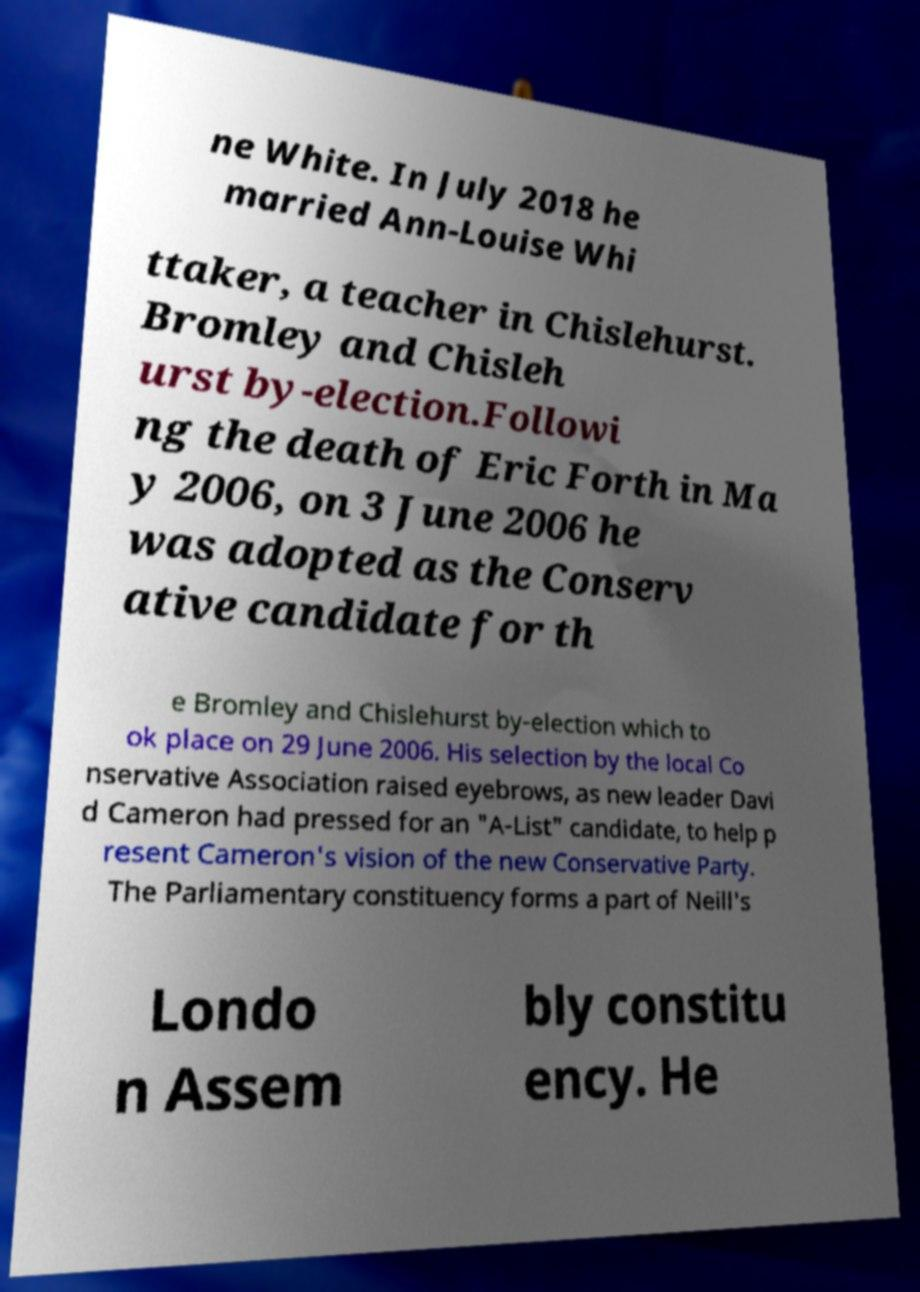There's text embedded in this image that I need extracted. Can you transcribe it verbatim? ne White. In July 2018 he married Ann-Louise Whi ttaker, a teacher in Chislehurst. Bromley and Chisleh urst by-election.Followi ng the death of Eric Forth in Ma y 2006, on 3 June 2006 he was adopted as the Conserv ative candidate for th e Bromley and Chislehurst by-election which to ok place on 29 June 2006. His selection by the local Co nservative Association raised eyebrows, as new leader Davi d Cameron had pressed for an "A-List" candidate, to help p resent Cameron's vision of the new Conservative Party. The Parliamentary constituency forms a part of Neill's Londo n Assem bly constitu ency. He 